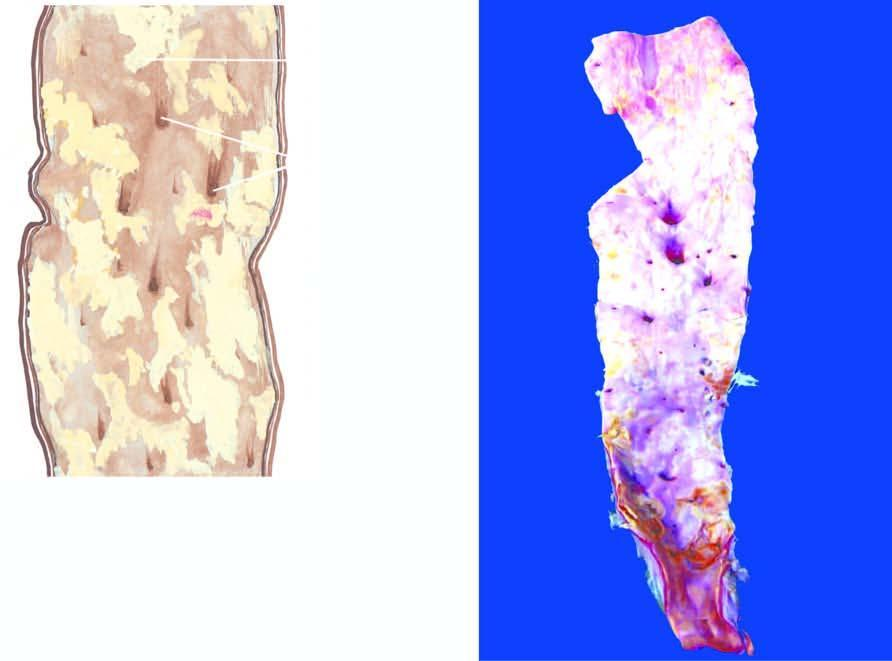does the opened up inner surface of the abdominal aorta show a variety of atheromatous lesions?
Answer the question using a single word or phrase. Yes 